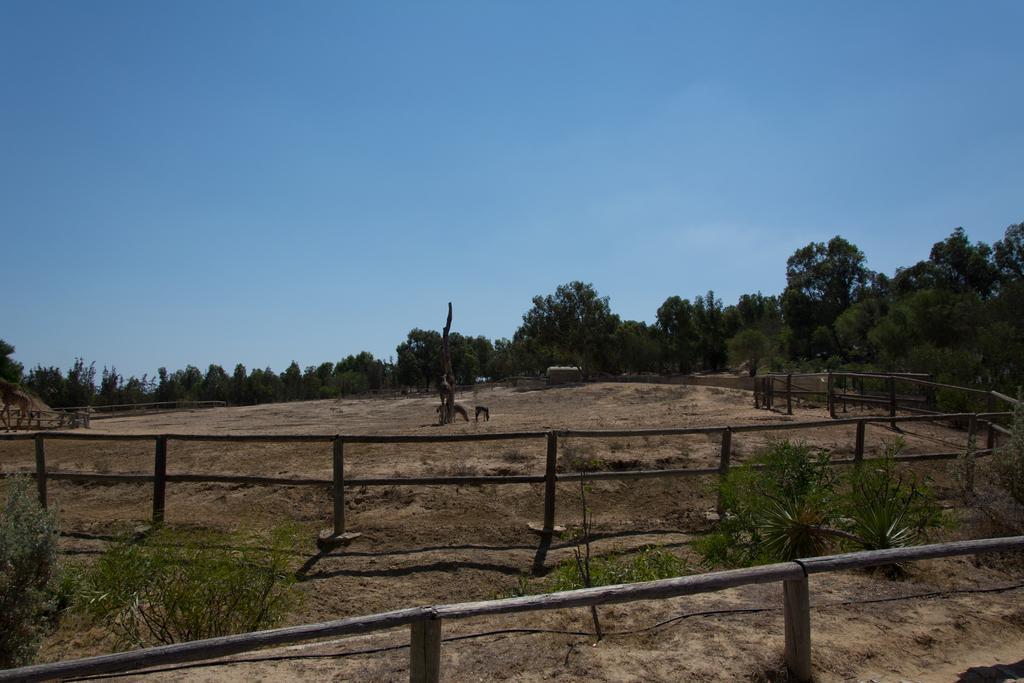Please provide a concise description of this image. In this picture we can see a fence from left to right. There are a few plants and some objects in the path. There are some plants from left to right. Sky is blue in color. 